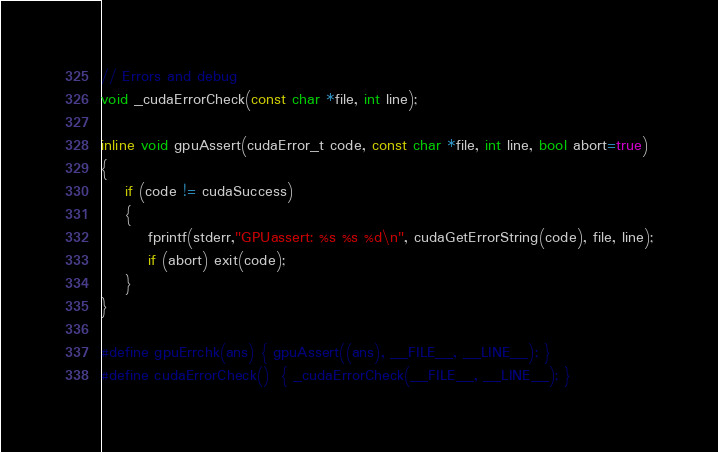Convert code to text. <code><loc_0><loc_0><loc_500><loc_500><_Cuda_>// Errors and debug
void _cudaErrorCheck(const char *file, int line);

inline void gpuAssert(cudaError_t code, const char *file, int line, bool abort=true)
{
    if (code != cudaSuccess)
    {
        fprintf(stderr,"GPUassert: %s %s %d\n", cudaGetErrorString(code), file, line);
        if (abort) exit(code);
    }
}

#define gpuErrchk(ans) { gpuAssert((ans), __FILE__, __LINE__); }
#define cudaErrorCheck()  { _cudaErrorCheck(__FILE__, __LINE__); }
</code> 